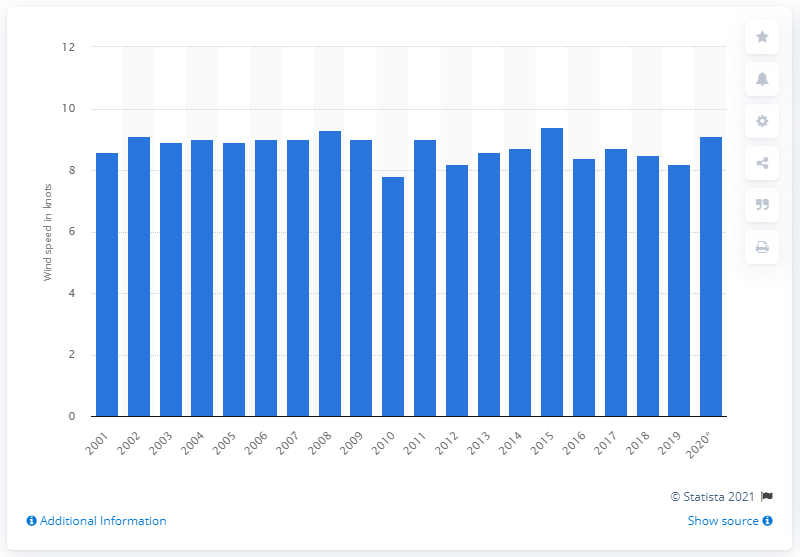Specify some key components in this picture. The lowest wind speed in the UK in 2010 was 7.8 miles per hour. 